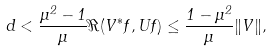<formula> <loc_0><loc_0><loc_500><loc_500>d < \frac { \mu ^ { 2 } - 1 } { \mu } \Re ( V ^ { \ast } f , U f ) \leq \frac { 1 - \mu ^ { 2 } } { \mu } \| V \| ,</formula> 